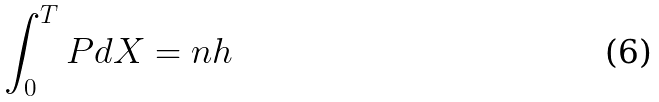Convert formula to latex. <formula><loc_0><loc_0><loc_500><loc_500>\int _ { 0 } ^ { T } P d X = n h</formula> 